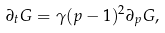<formula> <loc_0><loc_0><loc_500><loc_500>\partial _ { t } G = \gamma ( p - 1 ) ^ { 2 } \partial _ { p } G ,</formula> 